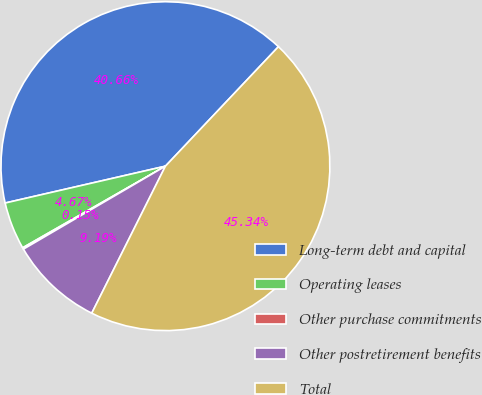<chart> <loc_0><loc_0><loc_500><loc_500><pie_chart><fcel>Long-term debt and capital<fcel>Operating leases<fcel>Other purchase commitments<fcel>Other postretirement benefits<fcel>Total<nl><fcel>40.66%<fcel>4.67%<fcel>0.15%<fcel>9.19%<fcel>45.34%<nl></chart> 